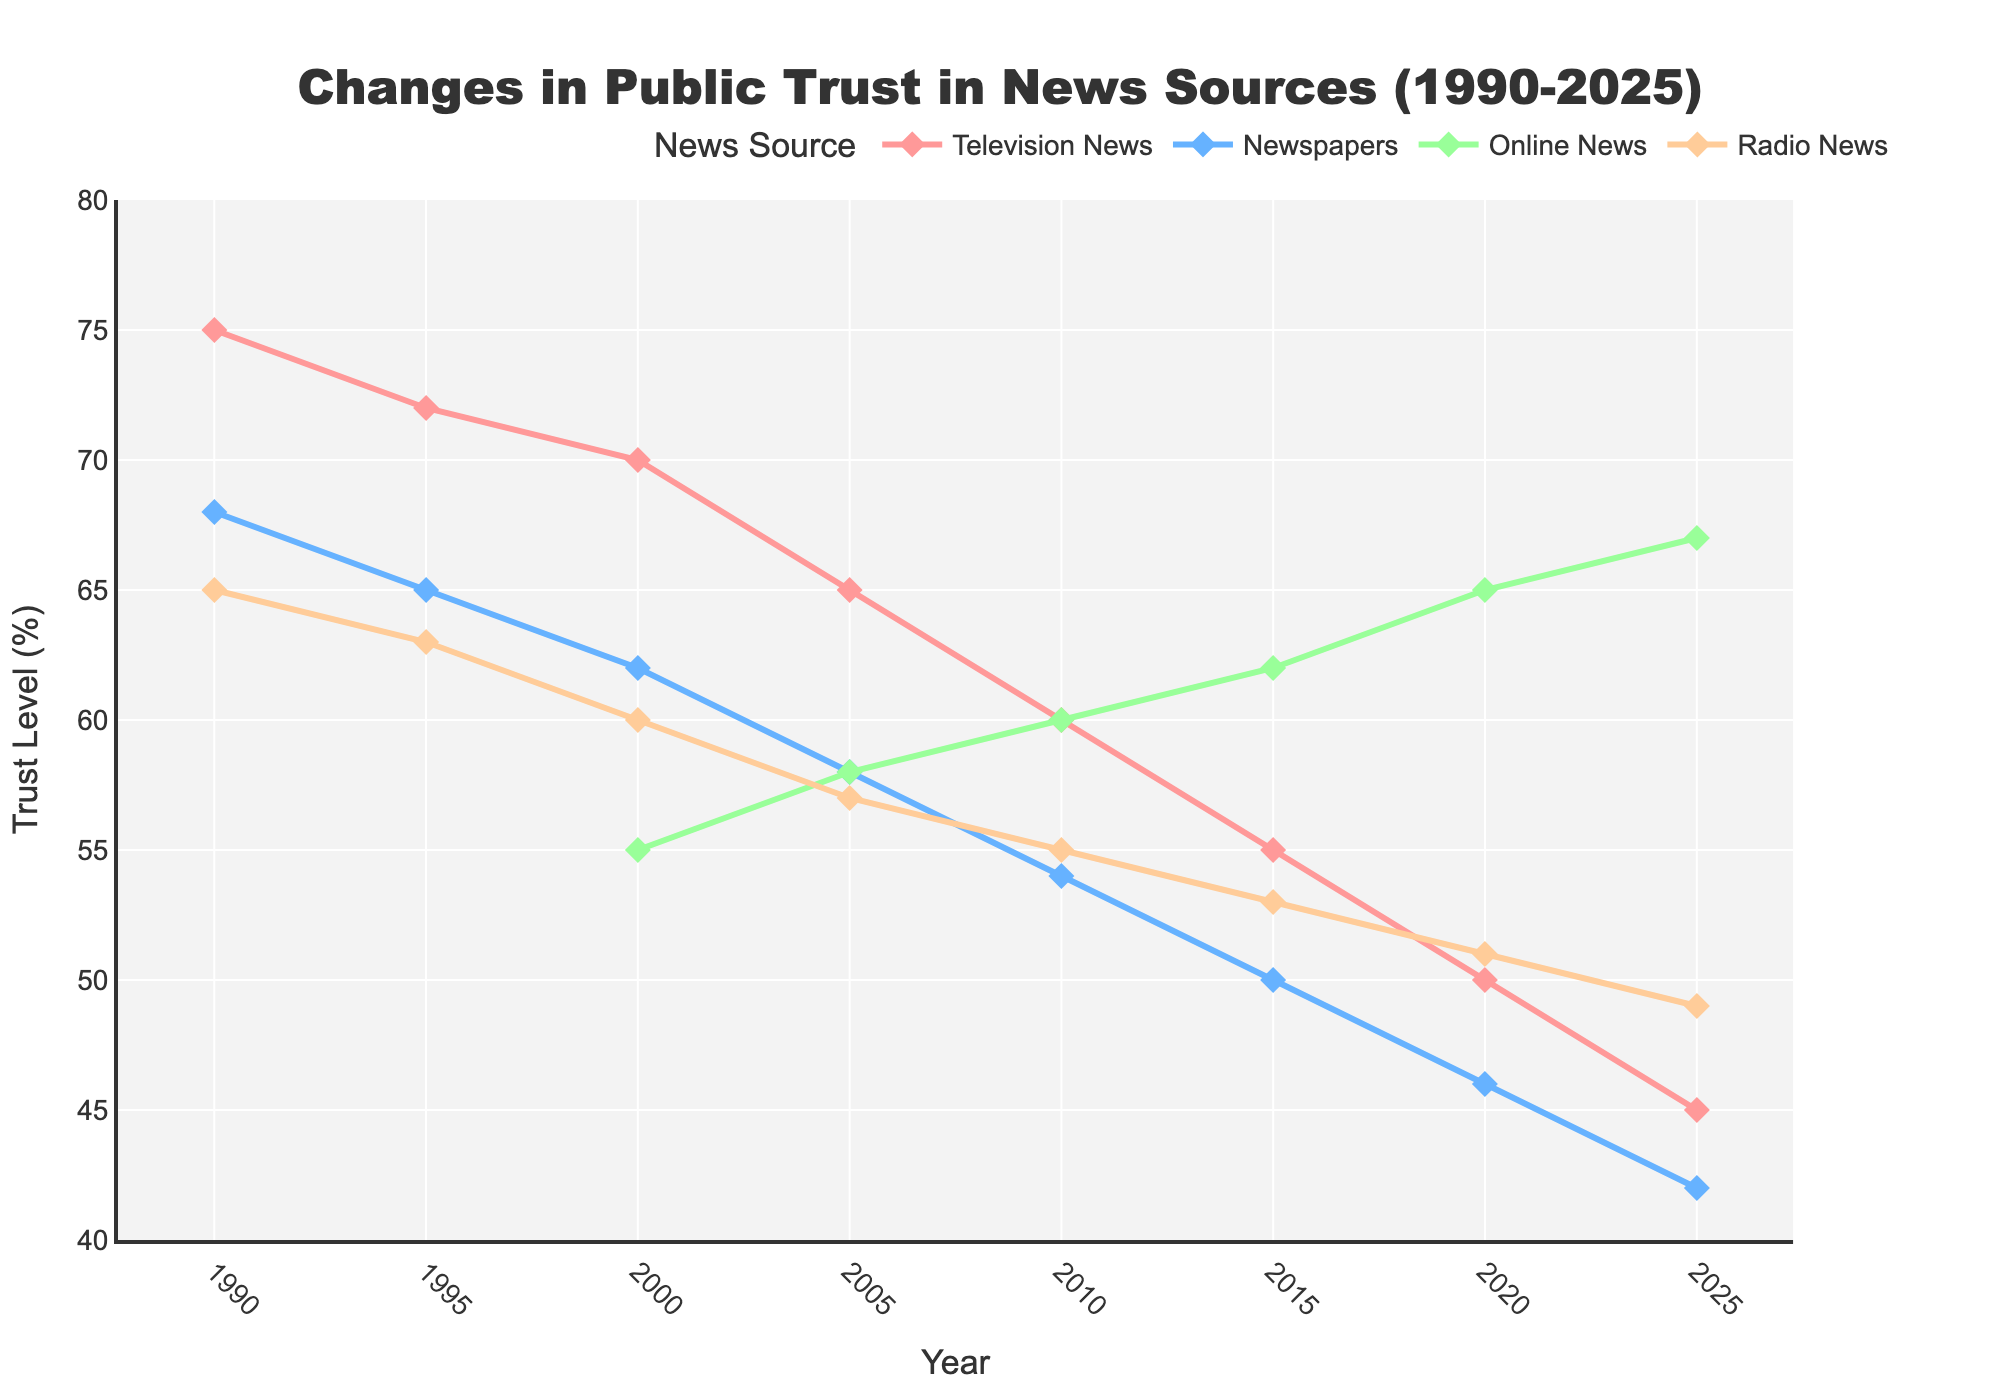What is the trust level change for Television News between 1990 and 2025? To find the change, subtract the trust level of Television News in 2025 from the trust level in 1990: 75 - 45.
Answer: 30 Which year saw the highest trust level for Online News? To identify this, review the Online News data and compare across the years, the highest value being 67 in 2025.
Answer: 2025 Compare the trust levels between Newspapers and Radio News in 2020. Which one is higher? In 2020, the trust level for Newspapers is 46, while for Radio News it is 51. Since 51 > 46, Radio News is higher.
Answer: Radio News What is the difference in trust levels between the highest and lowest points for Television News across all years? The highest point for Television News is 75 in 1990, and the lowest is 45 in 2025. The difference is 75 - 45.
Answer: 30 Which news source showed an increase in trust level over the years? By examining the trends, only Online News shows an increasing trend from its introduction in 2000 at 55 to 67 in 2025.
Answer: Online News Between 2015 and 2020, which news source experienced the largest decrease in trust level? Comparing the values for each source between 2015 and 2020: Television News (55-50=5), Newspapers (50-46=4), Online News (62-65=-3), Radio News (53-51=2). The largest decrease is Television News with 5.
Answer: Television News What is the average trust level of Radio News from 1990 to 2025? Sum the trust levels for Radio News across the years and divide by the number of years: (65 + 63 + 60 + 57 + 55 + 53 + 51 + 49) / 8.
Answer: 50.375 In what year did Newspapers and Television News have equal trust levels? Reviewing the data, the trust levels are never equal in any given year for Newspapers and Television News.
Answer: Never How did the trust level in Newspapers change from 1990 to 2025? To find the change, subtract the trust level of Newspapers in 2025 from the trust level in 1990: 68 - 42.
Answer: 26 In 2005, which news source had the lowest trust level? Review the data for 2005, and the news sources and their trust levels are: Television News (65), Newspapers (58), Online News (58), Radio News (57). Radio News is the lowest with 57.
Answer: Radio News 